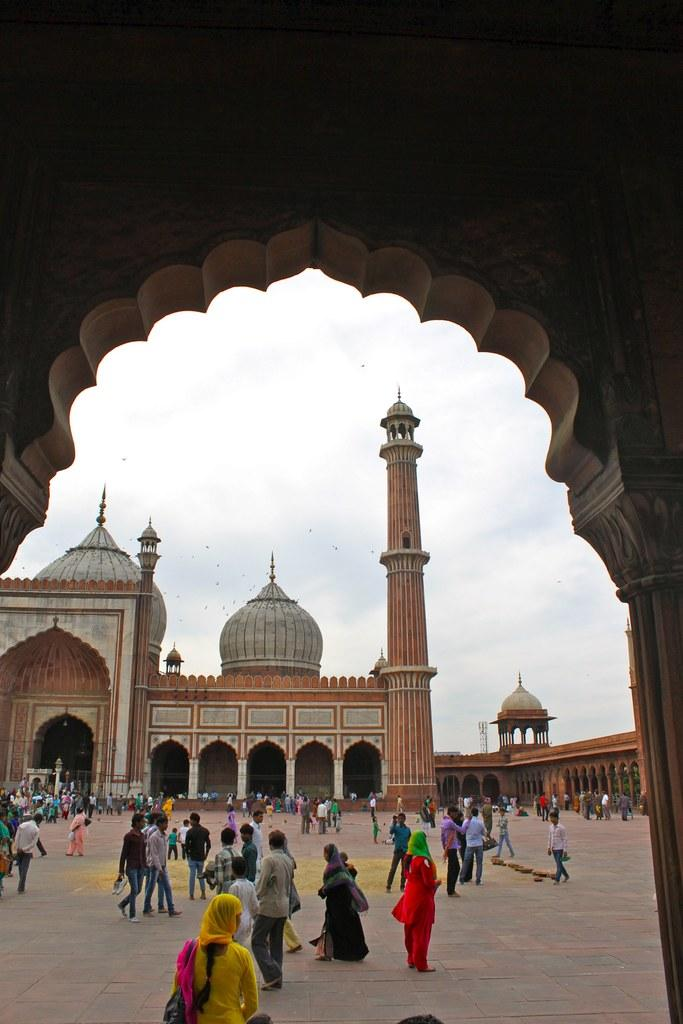What type of structure is present in the image? There is a building in the image. What part of the building can be seen in the image? The floor is visible in the image. What are the people in the image doing? There are people walking in the image. What is visible above the building in the image? The sky is visible in the image. What type of box can be seen in the image? There is no box present in the image. How does the disgust in the image manifest itself? There is no indication of disgust in the image. 